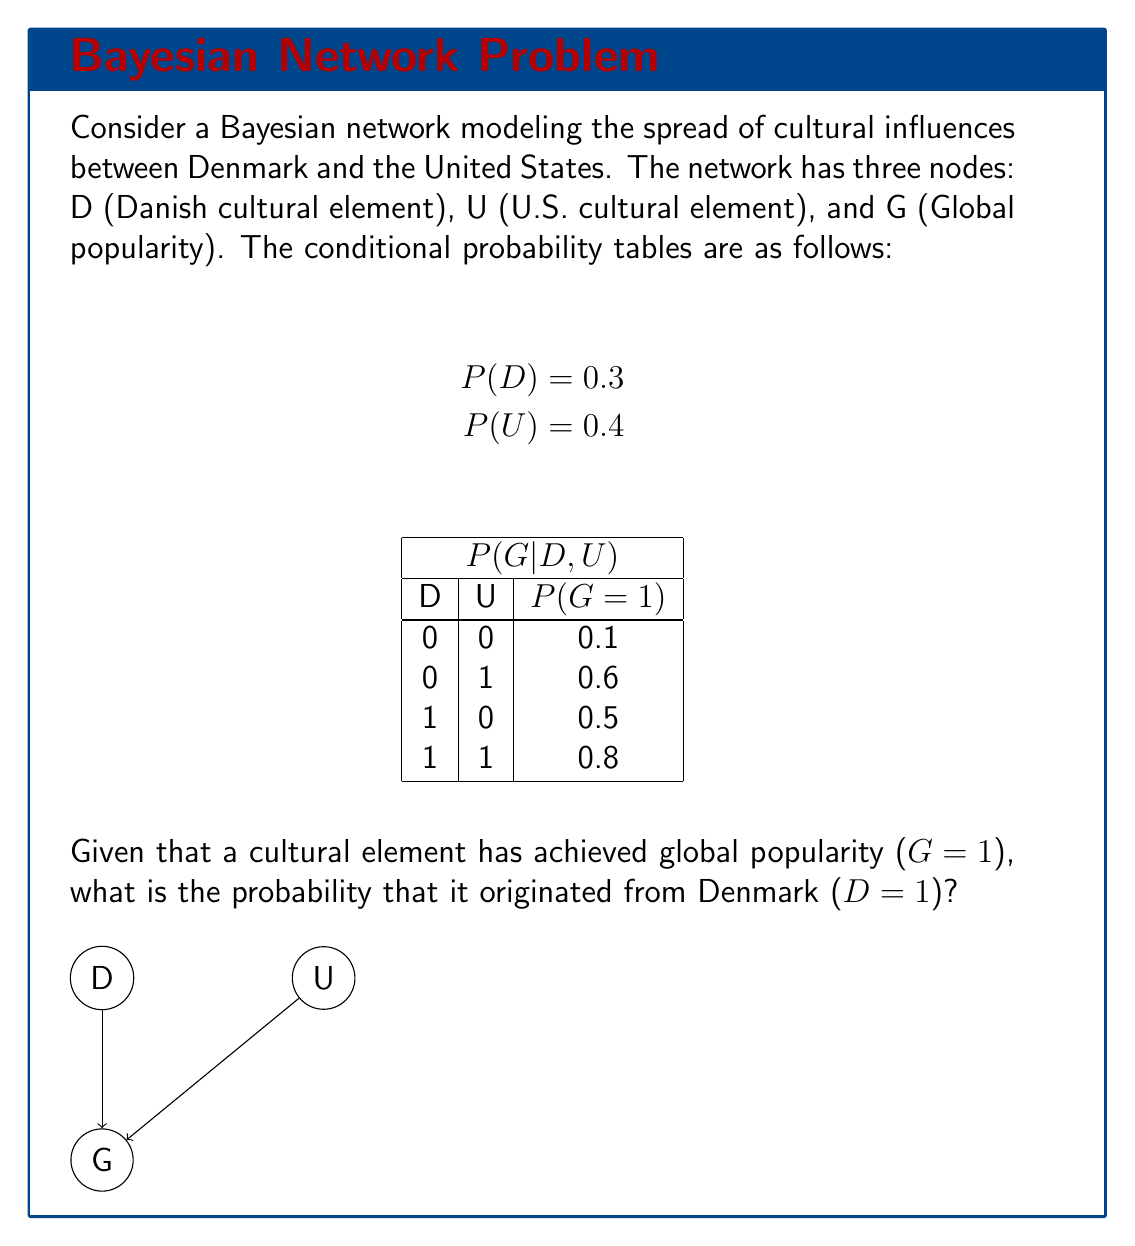Give your solution to this math problem. To solve this problem, we'll use Bayes' theorem and the law of total probability. Let's approach this step-by-step:

1) We want to find P(D=1|G=1). Using Bayes' theorem:

   $$P(D=1|G=1) = \frac{P(G=1|D=1)P(D=1)}{P(G=1)}$$

2) We know P(D=1) = 0.3 from the given information.

3) To find P(G=1|D=1), we need to use the law of total probability:

   $$P(G=1|D=1) = P(G=1|D=1,U=0)P(U=0) + P(G=1|D=1,U=1)P(U=1)$$
   $$= 0.5 \cdot 0.6 + 0.8 \cdot 0.4 = 0.3 + 0.32 = 0.62$$

4) To find P(G=1), we again use the law of total probability:

   $$P(G=1) = P(G=1|D=0,U=0)P(D=0)P(U=0) + P(G=1|D=0,U=1)P(D=0)P(U=1)$$
   $$+ P(G=1|D=1,U=0)P(D=1)P(U=0) + P(G=1|D=1,U=1)P(D=1)P(U=1)$$
   $$= 0.1 \cdot 0.7 \cdot 0.6 + 0.6 \cdot 0.7 \cdot 0.4 + 0.5 \cdot 0.3 \cdot 0.6 + 0.8 \cdot 0.3 \cdot 0.4$$
   $$= 0.042 + 0.168 + 0.09 + 0.096 = 0.396$$

5) Now we can plug these values into Bayes' theorem:

   $$P(D=1|G=1) = \frac{0.62 \cdot 0.3}{0.396} = \frac{0.186}{0.396} = 0.4697$$
Answer: 0.4697 